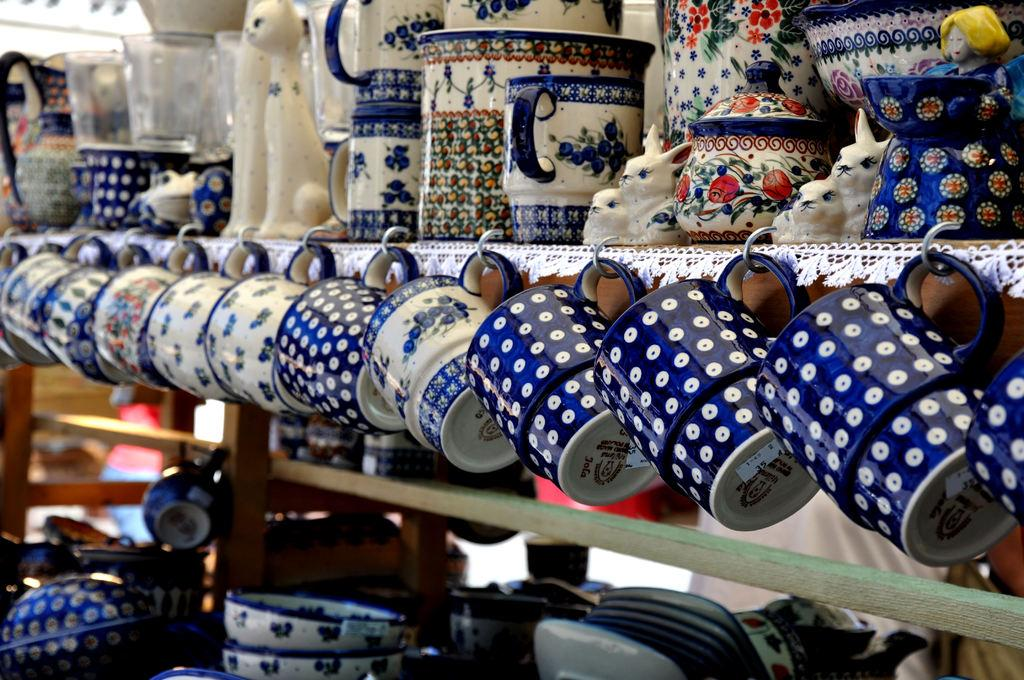What type of containers can be seen in the image? There are cups, jars, bowls, and vessels in the image. What else can be found in the image besides containers? There are toys in the image. How are the objects arranged in the image? The objects are placed in racks. What color is the crayon on the island in the image? There is no crayon or island present in the image. What type of cheese is being served in the vessels in the image? There is no cheese present in the image; the vessels contain cups, jars, bowls, and toys. 